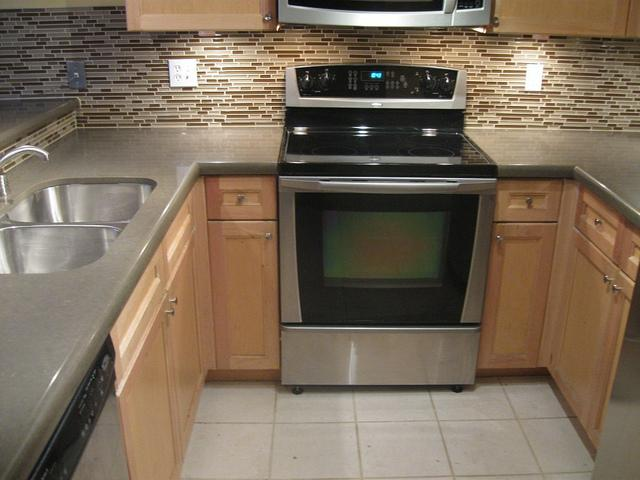What is the innermost color reflected off the center of the oven?

Choices:
A) yellow
B) blue
C) green
D) red red 